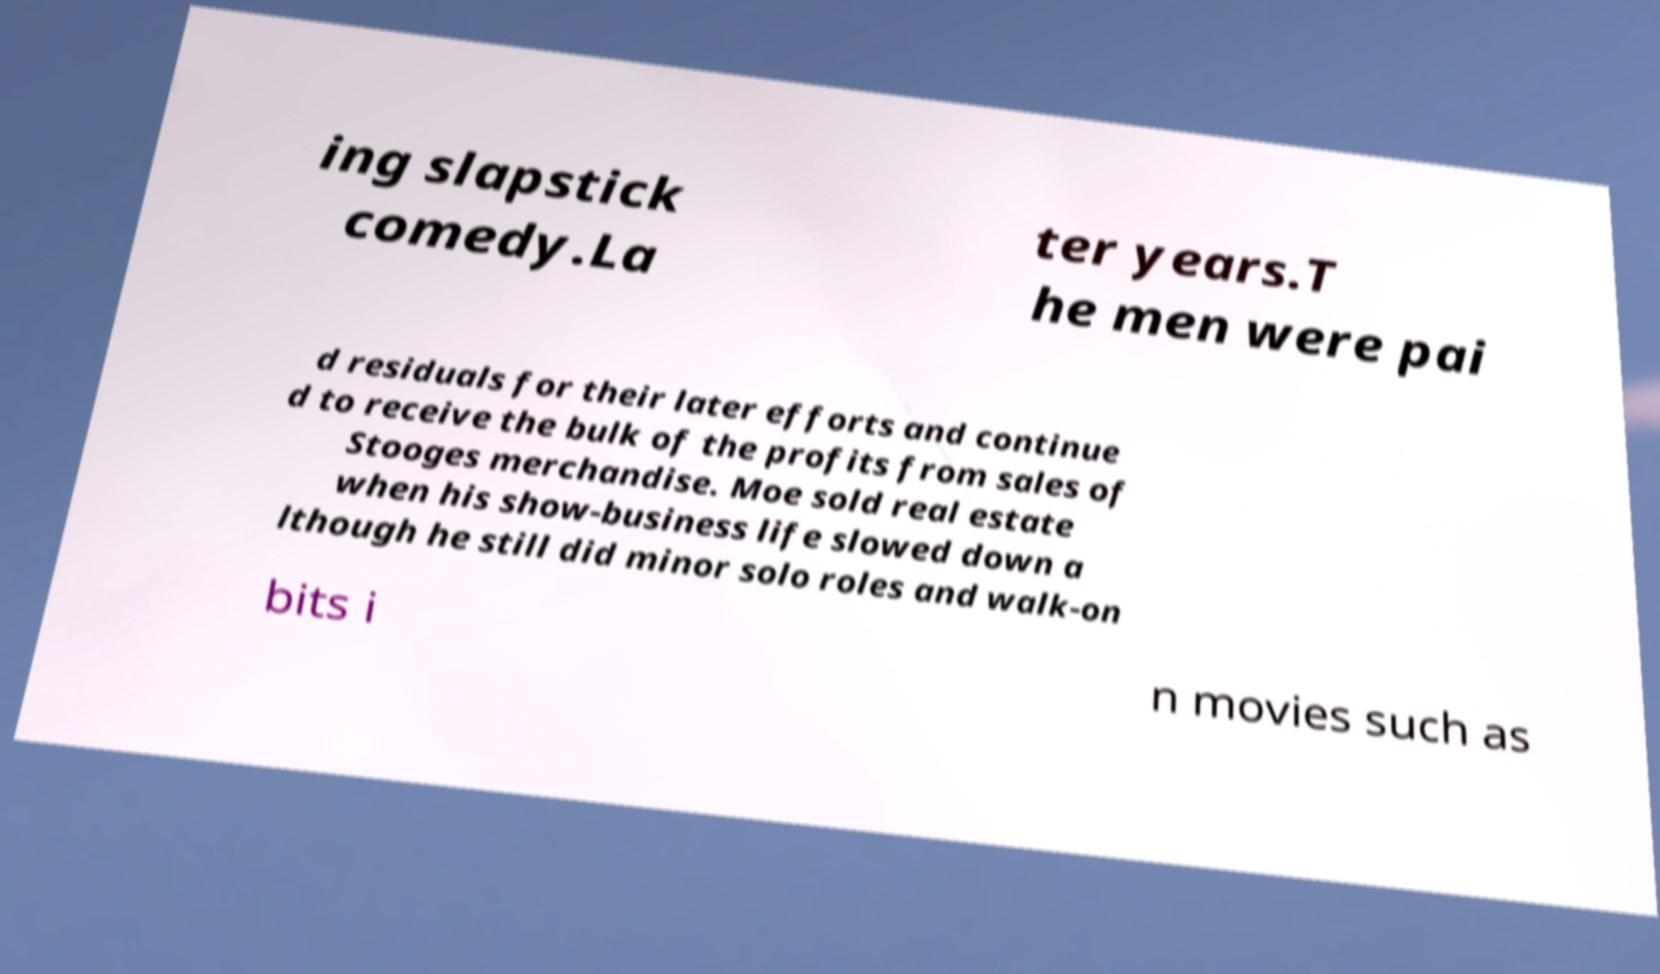Could you assist in decoding the text presented in this image and type it out clearly? ing slapstick comedy.La ter years.T he men were pai d residuals for their later efforts and continue d to receive the bulk of the profits from sales of Stooges merchandise. Moe sold real estate when his show-business life slowed down a lthough he still did minor solo roles and walk-on bits i n movies such as 